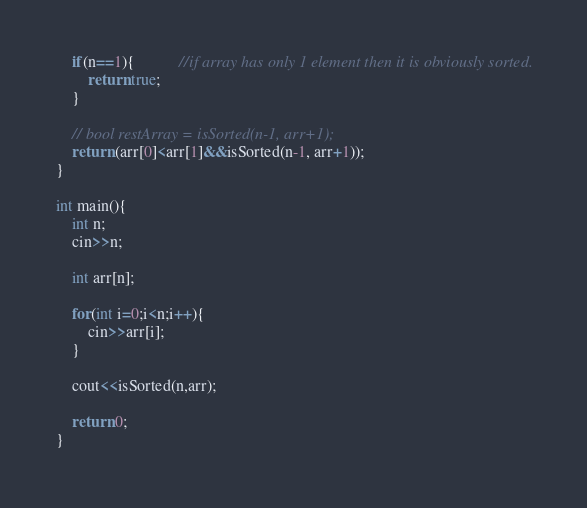Convert code to text. <code><loc_0><loc_0><loc_500><loc_500><_C++_>    if(n==1){           //if array has only 1 element then it is obviously sorted.
        return true;
    }

    // bool restArray = isSorted(n-1, arr+1);
    return (arr[0]<arr[1]&&isSorted(n-1, arr+1));
}

int main(){
    int n;
    cin>>n;

    int arr[n];

    for(int i=0;i<n;i++){
        cin>>arr[i];
    }

    cout<<isSorted(n,arr);

    return 0;
}</code> 